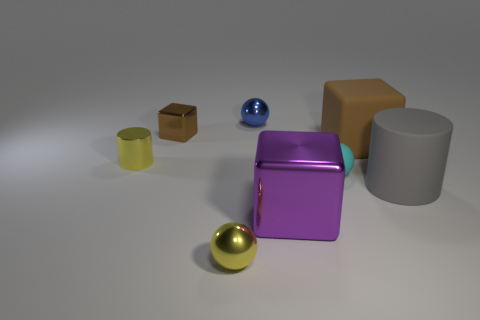Add 2 brown matte things. How many objects exist? 10 Subtract all cylinders. How many objects are left? 6 Subtract all big gray things. Subtract all cyan matte balls. How many objects are left? 6 Add 7 yellow cylinders. How many yellow cylinders are left? 8 Add 8 big gray cylinders. How many big gray cylinders exist? 9 Subtract 0 purple spheres. How many objects are left? 8 